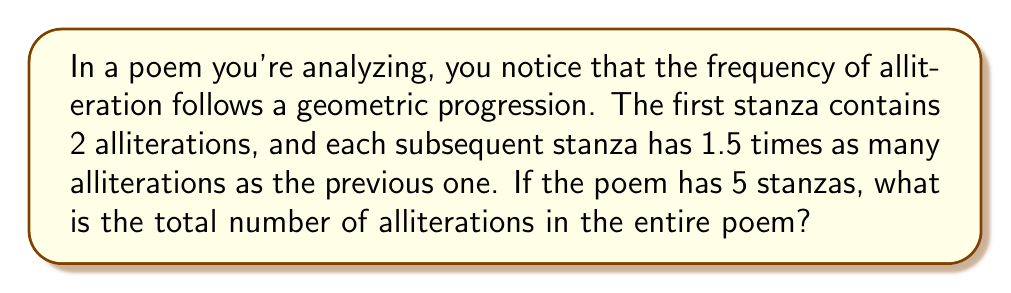Help me with this question. Let's approach this step-by-step:

1) We're dealing with a geometric progression where:
   - First term, $a = 2$ (alliterations in the first stanza)
   - Common ratio, $r = 1.5$ (each stanza has 1.5 times as many as the previous)
   - Number of terms, $n = 5$ (5 stanzas)

2) The number of alliterations in each stanza forms this sequence:
   2, 3, 4.5, 6.75, 10.125

3) To find the sum of this geometric progression, we use the formula:
   $$S_n = \frac{a(1-r^n)}{1-r}$$
   Where $S_n$ is the sum of n terms

4) Substituting our values:
   $$S_5 = \frac{2(1-1.5^5)}{1-1.5}$$

5) Let's calculate $1.5^5$:
   $1.5^5 = 7.59375$

6) Now our equation looks like:
   $$S_5 = \frac{2(1-7.59375)}{-0.5}$$

7) Simplifying:
   $$S_5 = \frac{2(-6.59375)}{-0.5} = \frac{13.1875}{0.5} = 26.375$$

8) Since we can't have fractional alliterations, we round to the nearest whole number:
   26.375 ≈ 26
Answer: 26 alliterations 